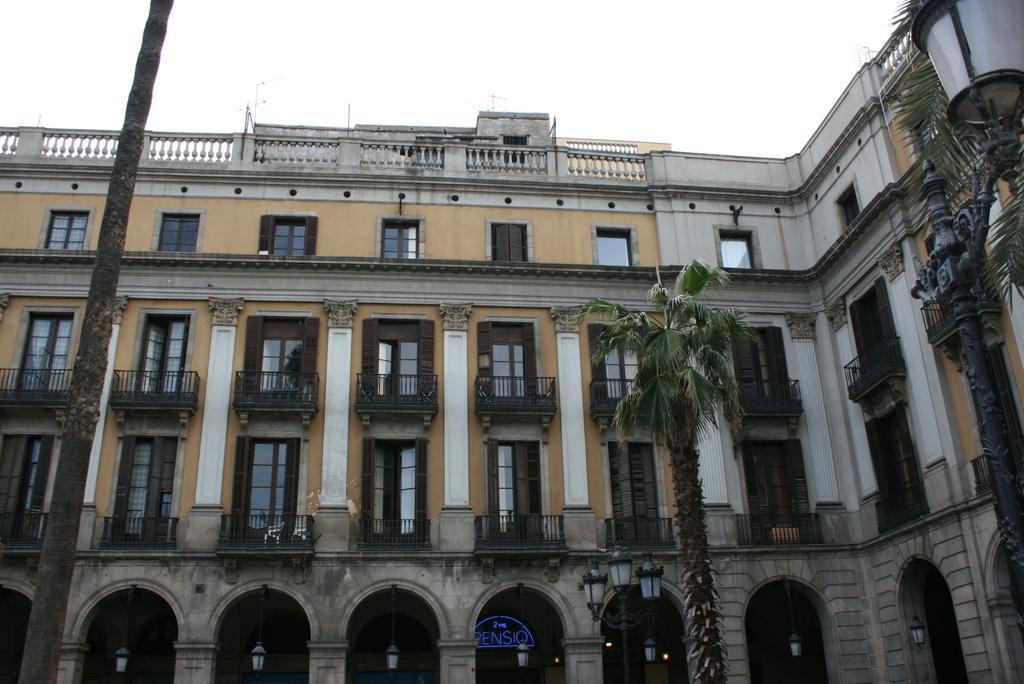Could you give a brief overview of what you see in this image? On the left side, there is a pole. On the right side, there is a light and tree is a tree. In the background, there is a building having glass windows, inside this building, there is a tree and there is sky. 